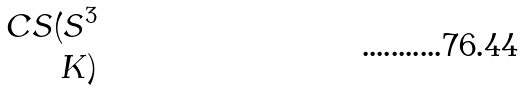<formula> <loc_0><loc_0><loc_500><loc_500>C S ( S ^ { 3 } \\ K )</formula> 